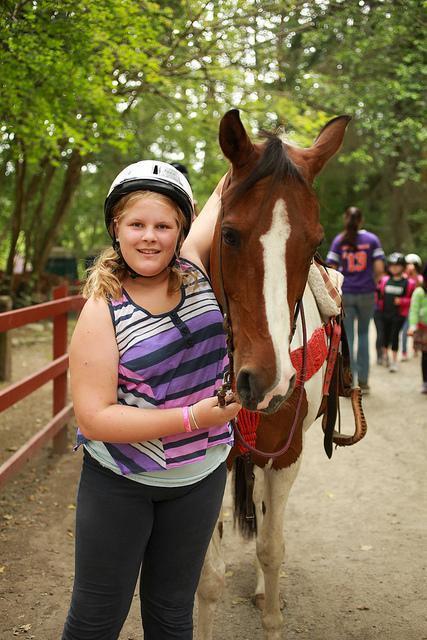How many people are in the photo?
Give a very brief answer. 3. How many handles does the refrigerator have?
Give a very brief answer. 0. 